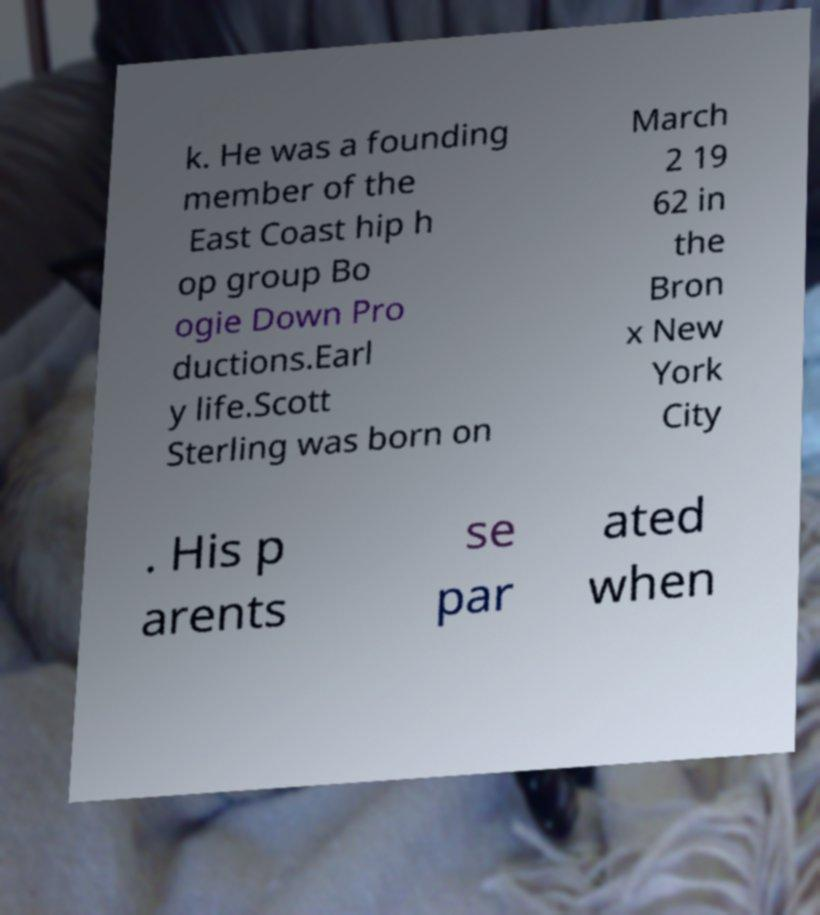I need the written content from this picture converted into text. Can you do that? k. He was a founding member of the East Coast hip h op group Bo ogie Down Pro ductions.Earl y life.Scott Sterling was born on March 2 19 62 in the Bron x New York City . His p arents se par ated when 